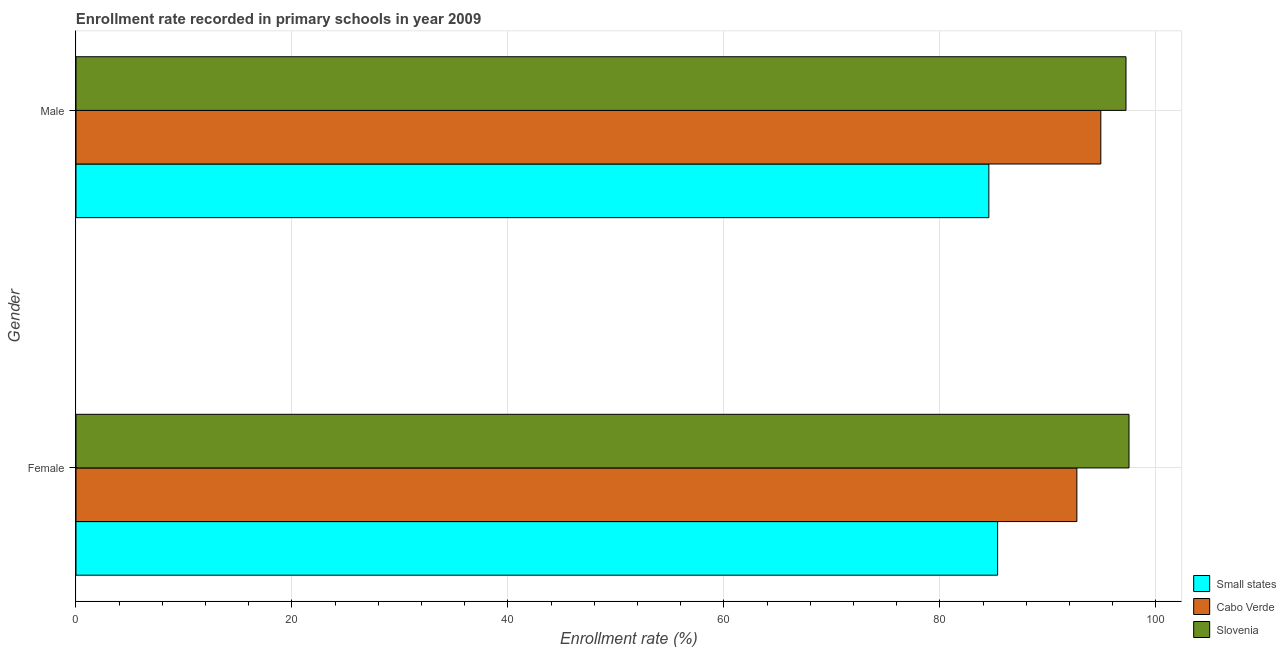How many groups of bars are there?
Your answer should be very brief. 2. Are the number of bars per tick equal to the number of legend labels?
Provide a succinct answer. Yes. How many bars are there on the 2nd tick from the bottom?
Provide a short and direct response. 3. What is the label of the 1st group of bars from the top?
Provide a short and direct response. Male. What is the enrollment rate of male students in Small states?
Keep it short and to the point. 84.52. Across all countries, what is the maximum enrollment rate of male students?
Keep it short and to the point. 97.22. Across all countries, what is the minimum enrollment rate of male students?
Your response must be concise. 84.52. In which country was the enrollment rate of male students maximum?
Provide a succinct answer. Slovenia. In which country was the enrollment rate of female students minimum?
Your answer should be compact. Small states. What is the total enrollment rate of female students in the graph?
Your answer should be compact. 275.51. What is the difference between the enrollment rate of male students in Small states and that in Slovenia?
Your answer should be compact. -12.7. What is the difference between the enrollment rate of female students in Cabo Verde and the enrollment rate of male students in Slovenia?
Your response must be concise. -4.55. What is the average enrollment rate of male students per country?
Provide a short and direct response. 92.21. What is the difference between the enrollment rate of male students and enrollment rate of female students in Small states?
Give a very brief answer. -0.81. What is the ratio of the enrollment rate of male students in Slovenia to that in Small states?
Provide a short and direct response. 1.15. In how many countries, is the enrollment rate of male students greater than the average enrollment rate of male students taken over all countries?
Your answer should be compact. 2. What does the 1st bar from the top in Female represents?
Give a very brief answer. Slovenia. What does the 1st bar from the bottom in Female represents?
Your response must be concise. Small states. Are all the bars in the graph horizontal?
Give a very brief answer. Yes. How many countries are there in the graph?
Provide a short and direct response. 3. What is the difference between two consecutive major ticks on the X-axis?
Offer a very short reply. 20. Are the values on the major ticks of X-axis written in scientific E-notation?
Offer a terse response. No. Does the graph contain any zero values?
Provide a short and direct response. No. Does the graph contain grids?
Provide a short and direct response. Yes. What is the title of the graph?
Ensure brevity in your answer.  Enrollment rate recorded in primary schools in year 2009. Does "Palau" appear as one of the legend labels in the graph?
Offer a very short reply. No. What is the label or title of the X-axis?
Offer a very short reply. Enrollment rate (%). What is the label or title of the Y-axis?
Give a very brief answer. Gender. What is the Enrollment rate (%) in Small states in Female?
Your answer should be very brief. 85.34. What is the Enrollment rate (%) of Cabo Verde in Female?
Provide a succinct answer. 92.67. What is the Enrollment rate (%) in Slovenia in Female?
Keep it short and to the point. 97.5. What is the Enrollment rate (%) of Small states in Male?
Provide a succinct answer. 84.52. What is the Enrollment rate (%) in Cabo Verde in Male?
Offer a terse response. 94.89. What is the Enrollment rate (%) of Slovenia in Male?
Offer a very short reply. 97.22. Across all Gender, what is the maximum Enrollment rate (%) of Small states?
Offer a very short reply. 85.34. Across all Gender, what is the maximum Enrollment rate (%) of Cabo Verde?
Ensure brevity in your answer.  94.89. Across all Gender, what is the maximum Enrollment rate (%) in Slovenia?
Your response must be concise. 97.5. Across all Gender, what is the minimum Enrollment rate (%) of Small states?
Offer a very short reply. 84.52. Across all Gender, what is the minimum Enrollment rate (%) of Cabo Verde?
Your response must be concise. 92.67. Across all Gender, what is the minimum Enrollment rate (%) in Slovenia?
Make the answer very short. 97.22. What is the total Enrollment rate (%) in Small states in the graph?
Make the answer very short. 169.86. What is the total Enrollment rate (%) of Cabo Verde in the graph?
Your answer should be very brief. 187.56. What is the total Enrollment rate (%) in Slovenia in the graph?
Make the answer very short. 194.72. What is the difference between the Enrollment rate (%) in Small states in Female and that in Male?
Provide a short and direct response. 0.81. What is the difference between the Enrollment rate (%) in Cabo Verde in Female and that in Male?
Give a very brief answer. -2.22. What is the difference between the Enrollment rate (%) in Slovenia in Female and that in Male?
Your answer should be very brief. 0.28. What is the difference between the Enrollment rate (%) of Small states in Female and the Enrollment rate (%) of Cabo Verde in Male?
Your answer should be very brief. -9.55. What is the difference between the Enrollment rate (%) of Small states in Female and the Enrollment rate (%) of Slovenia in Male?
Make the answer very short. -11.89. What is the difference between the Enrollment rate (%) of Cabo Verde in Female and the Enrollment rate (%) of Slovenia in Male?
Offer a terse response. -4.55. What is the average Enrollment rate (%) of Small states per Gender?
Give a very brief answer. 84.93. What is the average Enrollment rate (%) in Cabo Verde per Gender?
Ensure brevity in your answer.  93.78. What is the average Enrollment rate (%) in Slovenia per Gender?
Provide a succinct answer. 97.36. What is the difference between the Enrollment rate (%) of Small states and Enrollment rate (%) of Cabo Verde in Female?
Your response must be concise. -7.34. What is the difference between the Enrollment rate (%) of Small states and Enrollment rate (%) of Slovenia in Female?
Your answer should be compact. -12.16. What is the difference between the Enrollment rate (%) of Cabo Verde and Enrollment rate (%) of Slovenia in Female?
Give a very brief answer. -4.83. What is the difference between the Enrollment rate (%) in Small states and Enrollment rate (%) in Cabo Verde in Male?
Give a very brief answer. -10.37. What is the difference between the Enrollment rate (%) in Small states and Enrollment rate (%) in Slovenia in Male?
Ensure brevity in your answer.  -12.7. What is the difference between the Enrollment rate (%) in Cabo Verde and Enrollment rate (%) in Slovenia in Male?
Your answer should be very brief. -2.33. What is the ratio of the Enrollment rate (%) of Small states in Female to that in Male?
Give a very brief answer. 1.01. What is the ratio of the Enrollment rate (%) in Cabo Verde in Female to that in Male?
Provide a succinct answer. 0.98. What is the difference between the highest and the second highest Enrollment rate (%) in Small states?
Your response must be concise. 0.81. What is the difference between the highest and the second highest Enrollment rate (%) in Cabo Verde?
Your answer should be very brief. 2.22. What is the difference between the highest and the second highest Enrollment rate (%) in Slovenia?
Make the answer very short. 0.28. What is the difference between the highest and the lowest Enrollment rate (%) of Small states?
Provide a succinct answer. 0.81. What is the difference between the highest and the lowest Enrollment rate (%) in Cabo Verde?
Give a very brief answer. 2.22. What is the difference between the highest and the lowest Enrollment rate (%) of Slovenia?
Your answer should be compact. 0.28. 